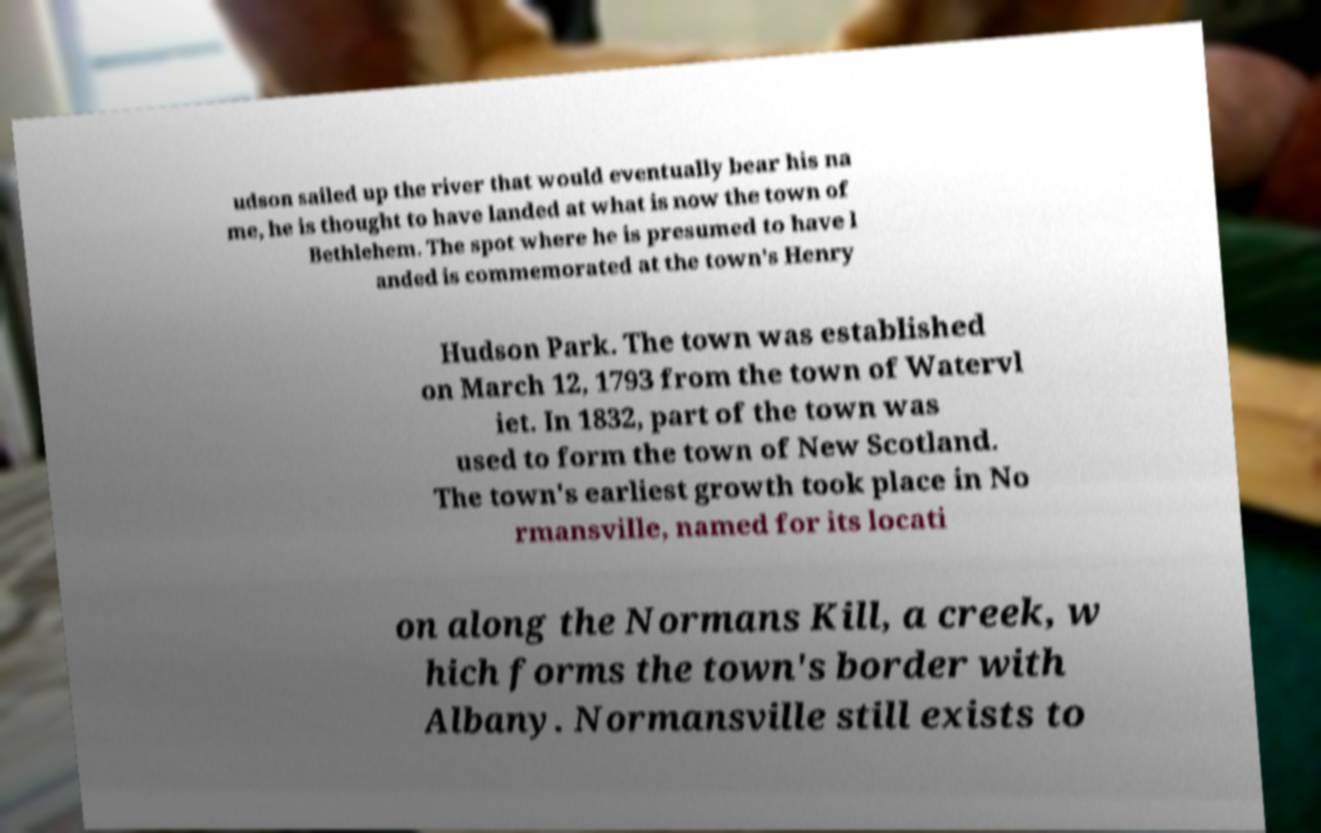What messages or text are displayed in this image? I need them in a readable, typed format. udson sailed up the river that would eventually bear his na me, he is thought to have landed at what is now the town of Bethlehem. The spot where he is presumed to have l anded is commemorated at the town's Henry Hudson Park. The town was established on March 12, 1793 from the town of Watervl iet. In 1832, part of the town was used to form the town of New Scotland. The town's earliest growth took place in No rmansville, named for its locati on along the Normans Kill, a creek, w hich forms the town's border with Albany. Normansville still exists to 